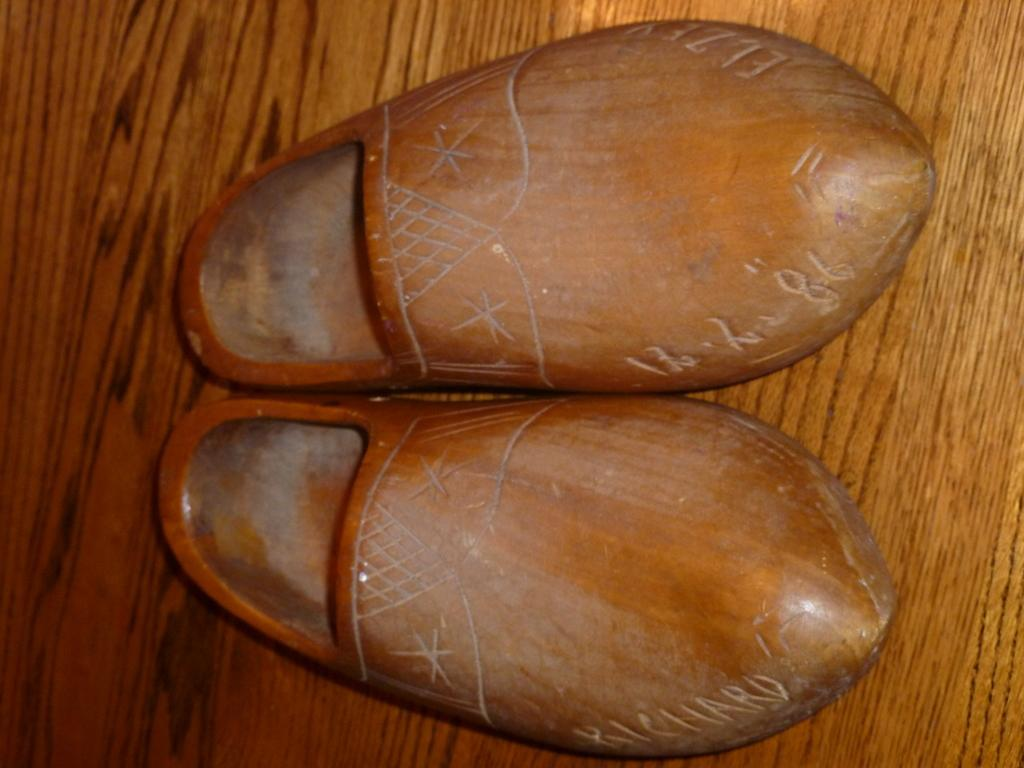What type of objects can be seen in the image? There are shoes in the image. What else is present in the image besides the shoes? There is text in the image. What angle is the knee shown at in the image? There is no knee present in the image, so it is not possible to determine the angle. 